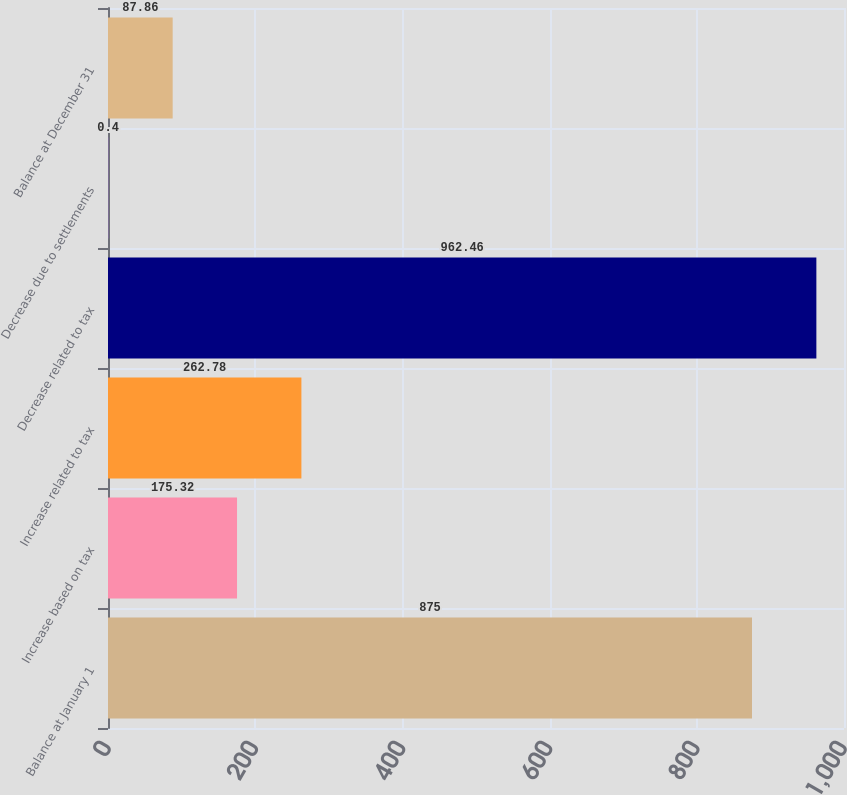Convert chart. <chart><loc_0><loc_0><loc_500><loc_500><bar_chart><fcel>Balance at January 1<fcel>Increase based on tax<fcel>Increase related to tax<fcel>Decrease related to tax<fcel>Decrease due to settlements<fcel>Balance at December 31<nl><fcel>875<fcel>175.32<fcel>262.78<fcel>962.46<fcel>0.4<fcel>87.86<nl></chart> 